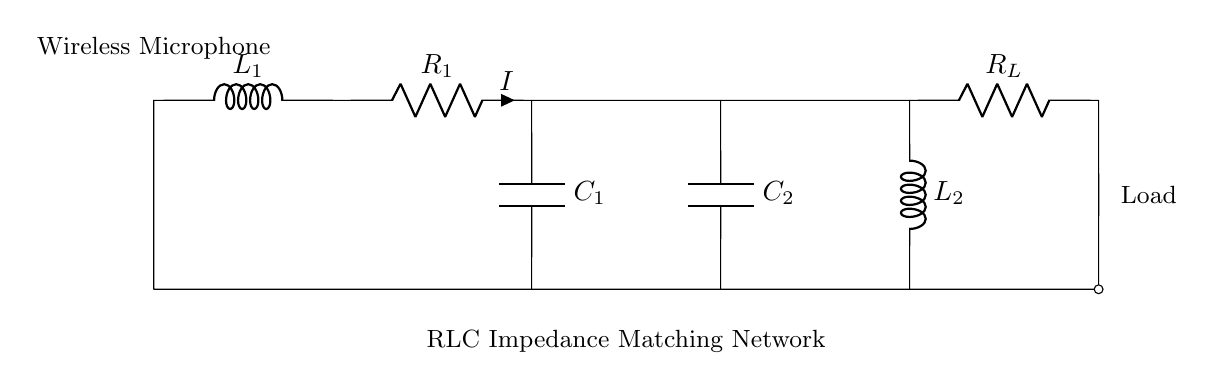What is the load resistance in this circuit? The load resistance is represented as R_L in the circuit diagram and is located at the final connection point on the right side.
Answer: R_L What component connects the antenna to R_1? The component connecting the antenna to R_1 is the inductor L_1, which is the first component in the path from the antenna to the load.
Answer: L_1 How many capacitors are present in this RLC circuit? The circuit contains two capacitors, C_1 and C_2, as indicated by the labels next to the components.
Answer: Two What is the purpose of the RLC matching network in the context of a wireless microphone? The purpose of the RLC matching network is to maximize power transfer from the microphone, ensuring efficient transmission by matching impedances between stages of the circuit.
Answer: Maximize power transfer What is the configuration of the capacitors in this circuit? The two capacitors C_1 and C_2 are configured in series between the resistive and inductive components, affecting the overall impedance matching.
Answer: Series What is the total inductance of the circuit if both inductors are connected in series? The total inductance can be calculated by simply adding the inductances of L_1 and L_2, as series connection sums inductances.
Answer: L_1 + L_2 What function do the resistances R_1 and R_L serve in this circuit? The resistances R_1 and R_L serve to dissipate energy in the circuit, contributing to the overall impedance matching and stability of the transmission system.
Answer: Energy dissipation 